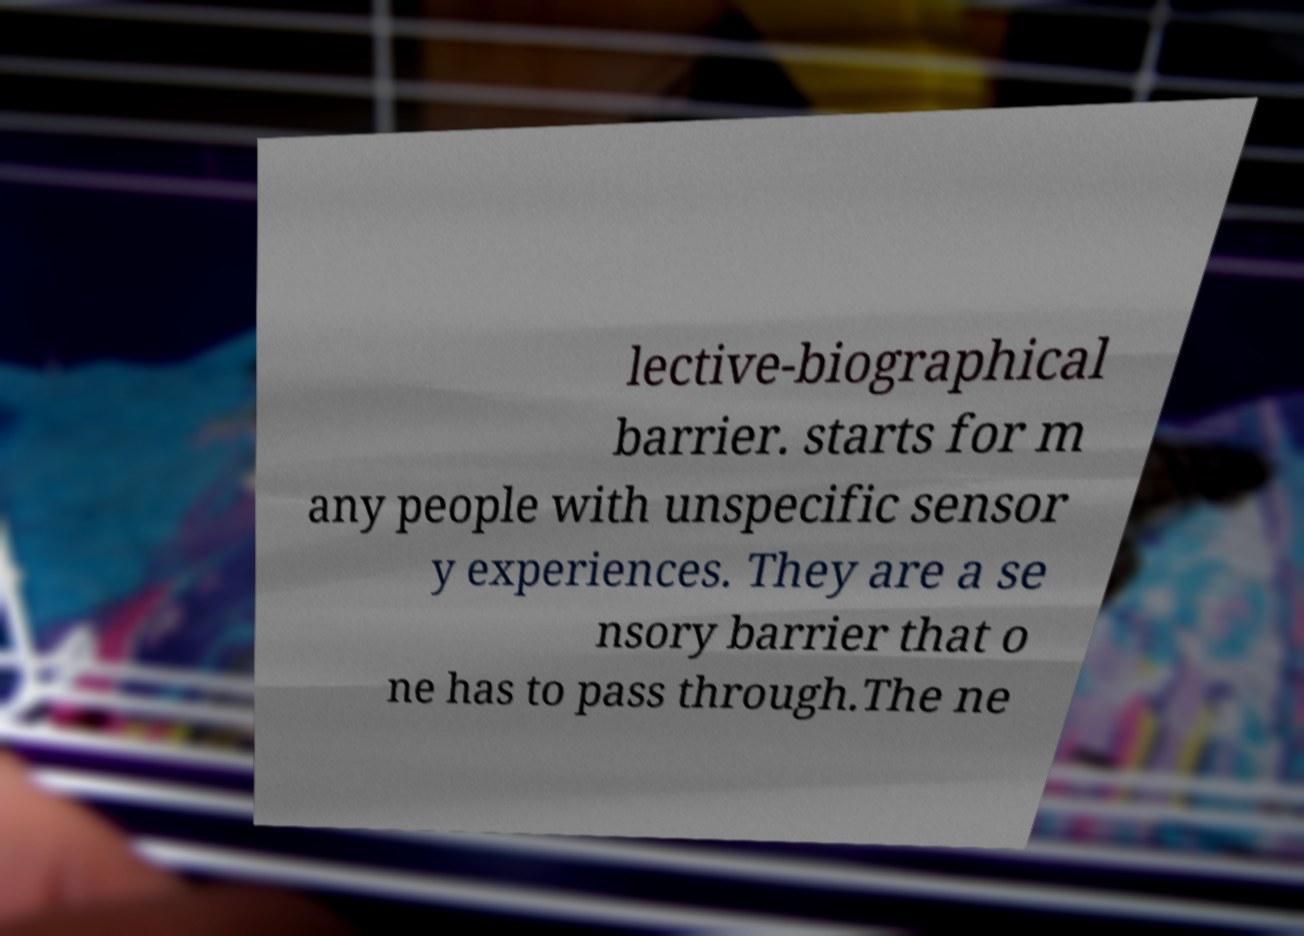What messages or text are displayed in this image? I need them in a readable, typed format. lective-biographical barrier. starts for m any people with unspecific sensor y experiences. They are a se nsory barrier that o ne has to pass through.The ne 